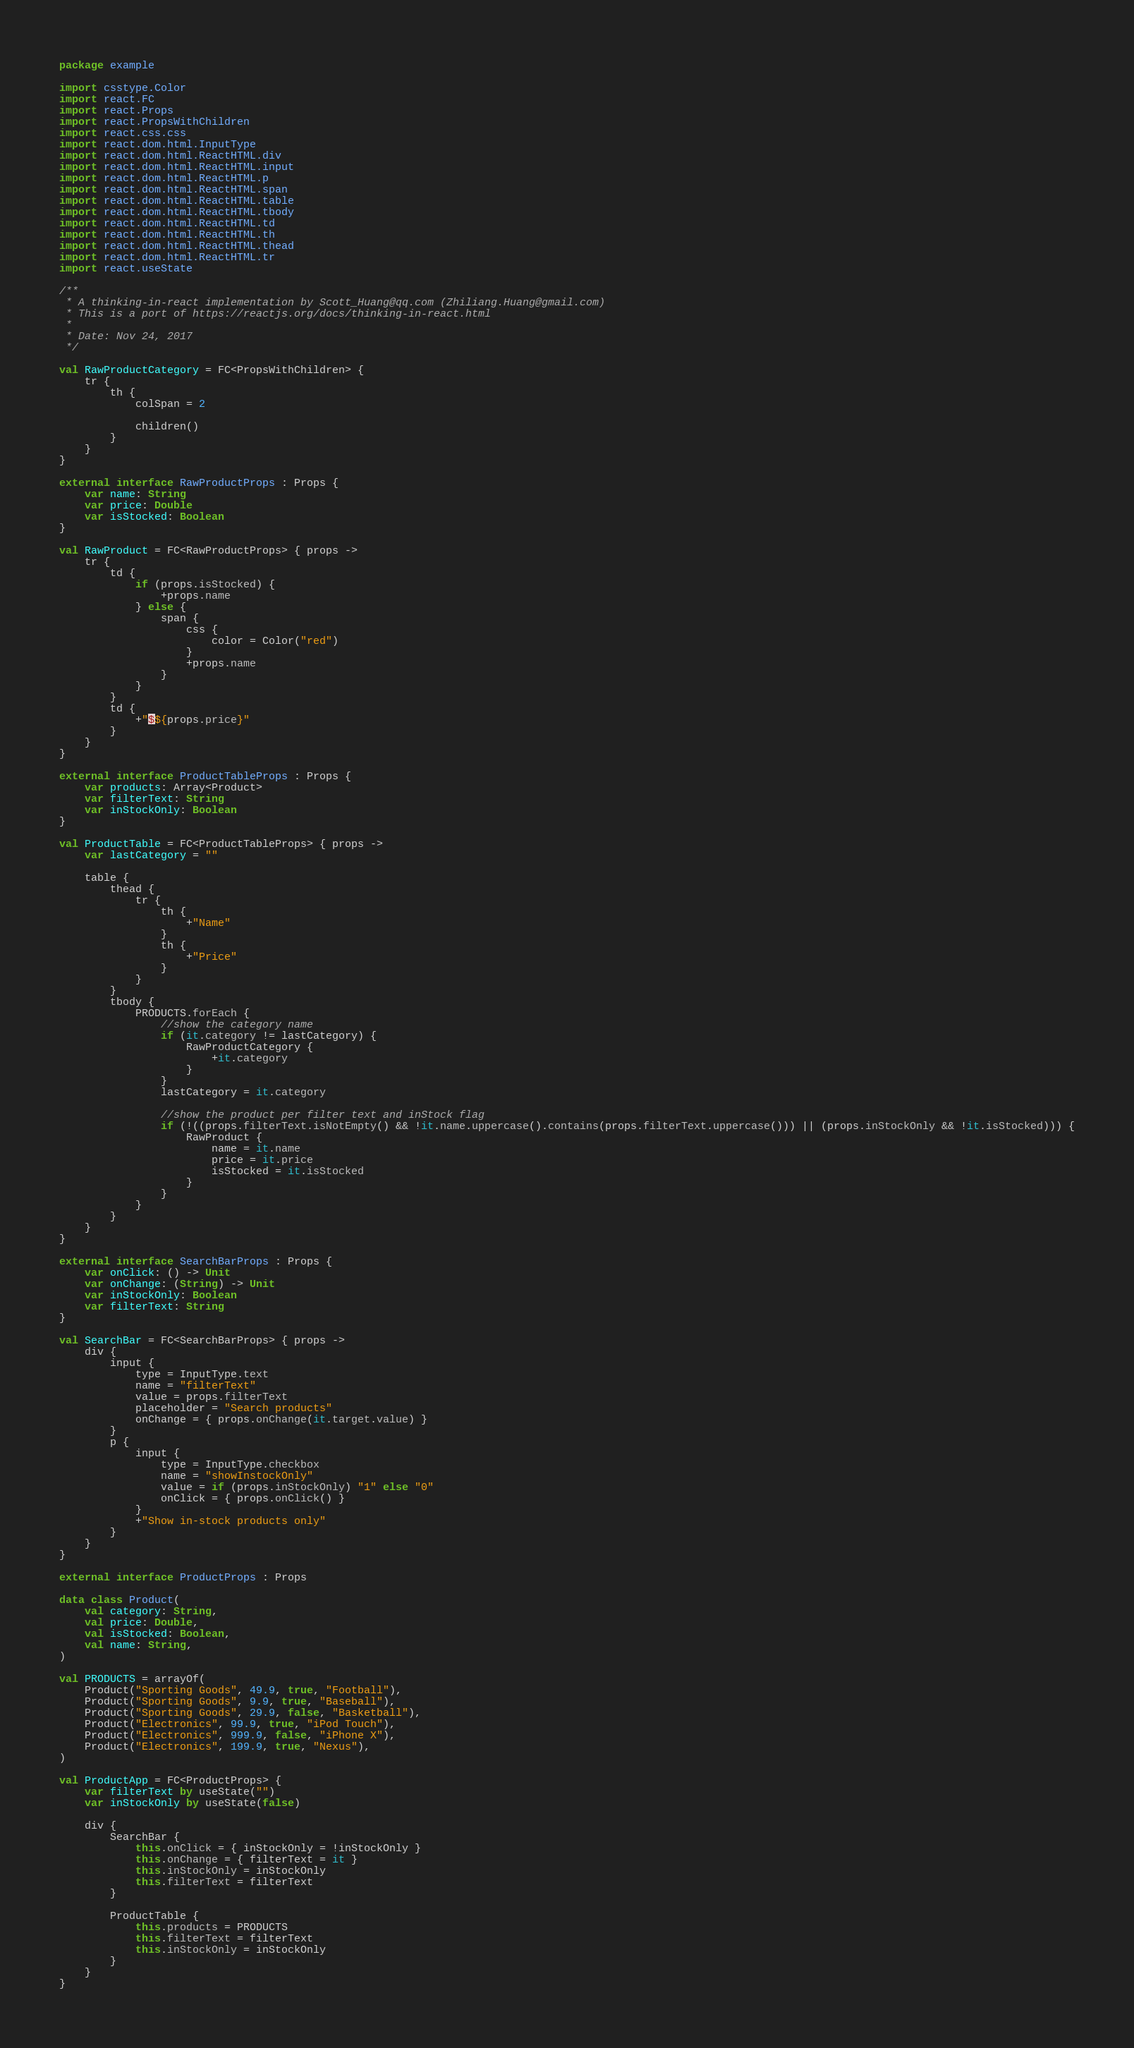Convert code to text. <code><loc_0><loc_0><loc_500><loc_500><_Kotlin_>package example

import csstype.Color
import react.FC
import react.Props
import react.PropsWithChildren
import react.css.css
import react.dom.html.InputType
import react.dom.html.ReactHTML.div
import react.dom.html.ReactHTML.input
import react.dom.html.ReactHTML.p
import react.dom.html.ReactHTML.span
import react.dom.html.ReactHTML.table
import react.dom.html.ReactHTML.tbody
import react.dom.html.ReactHTML.td
import react.dom.html.ReactHTML.th
import react.dom.html.ReactHTML.thead
import react.dom.html.ReactHTML.tr
import react.useState

/**
 * A thinking-in-react implementation by Scott_Huang@qq.com (Zhiliang.Huang@gmail.com)
 * This is a port of https://reactjs.org/docs/thinking-in-react.html
 *
 * Date: Nov 24, 2017
 */

val RawProductCategory = FC<PropsWithChildren> {
    tr {
        th {
            colSpan = 2

            children()
        }
    }
}

external interface RawProductProps : Props {
    var name: String
    var price: Double
    var isStocked: Boolean
}

val RawProduct = FC<RawProductProps> { props ->
    tr {
        td {
            if (props.isStocked) {
                +props.name
            } else {
                span {
                    css {
                        color = Color("red")
                    }
                    +props.name
                }
            }
        }
        td {
            +"$${props.price}"
        }
    }
}

external interface ProductTableProps : Props {
    var products: Array<Product>
    var filterText: String
    var inStockOnly: Boolean
}

val ProductTable = FC<ProductTableProps> { props ->
    var lastCategory = ""

    table {
        thead {
            tr {
                th {
                    +"Name"
                }
                th {
                    +"Price"
                }
            }
        }
        tbody {
            PRODUCTS.forEach {
                //show the category name
                if (it.category != lastCategory) {
                    RawProductCategory {
                        +it.category
                    }
                }
                lastCategory = it.category

                //show the product per filter text and inStock flag
                if (!((props.filterText.isNotEmpty() && !it.name.uppercase().contains(props.filterText.uppercase())) || (props.inStockOnly && !it.isStocked))) {
                    RawProduct {
                        name = it.name
                        price = it.price
                        isStocked = it.isStocked
                    }
                }
            }
        }
    }
}

external interface SearchBarProps : Props {
    var onClick: () -> Unit
    var onChange: (String) -> Unit
    var inStockOnly: Boolean
    var filterText: String
}

val SearchBar = FC<SearchBarProps> { props ->
    div {
        input {
            type = InputType.text
            name = "filterText"
            value = props.filterText
            placeholder = "Search products"
            onChange = { props.onChange(it.target.value) }
        }
        p {
            input {
                type = InputType.checkbox
                name = "showInstockOnly"
                value = if (props.inStockOnly) "1" else "0"
                onClick = { props.onClick() }
            }
            +"Show in-stock products only"
        }
    }
}

external interface ProductProps : Props

data class Product(
    val category: String,
    val price: Double,
    val isStocked: Boolean,
    val name: String,
)

val PRODUCTS = arrayOf(
    Product("Sporting Goods", 49.9, true, "Football"),
    Product("Sporting Goods", 9.9, true, "Baseball"),
    Product("Sporting Goods", 29.9, false, "Basketball"),
    Product("Electronics", 99.9, true, "iPod Touch"),
    Product("Electronics", 999.9, false, "iPhone X"),
    Product("Electronics", 199.9, true, "Nexus"),
)

val ProductApp = FC<ProductProps> {
    var filterText by useState("")
    var inStockOnly by useState(false)

    div {
        SearchBar {
            this.onClick = { inStockOnly = !inStockOnly }
            this.onChange = { filterText = it }
            this.inStockOnly = inStockOnly
            this.filterText = filterText
        }

        ProductTable {
            this.products = PRODUCTS
            this.filterText = filterText
            this.inStockOnly = inStockOnly
        }
    }
}
</code> 